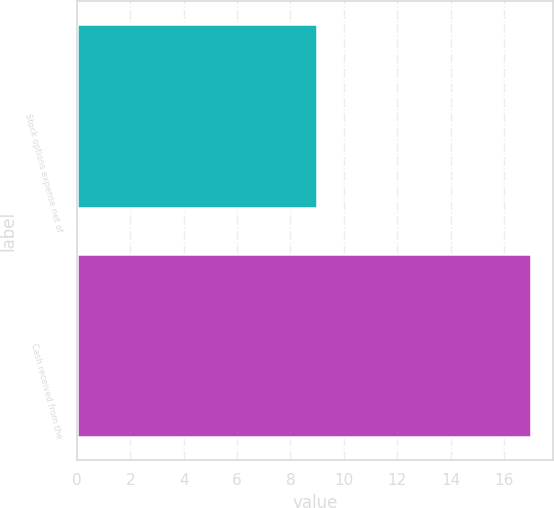Convert chart to OTSL. <chart><loc_0><loc_0><loc_500><loc_500><bar_chart><fcel>Stock options expense net of<fcel>Cash received from the<nl><fcel>9<fcel>17<nl></chart> 